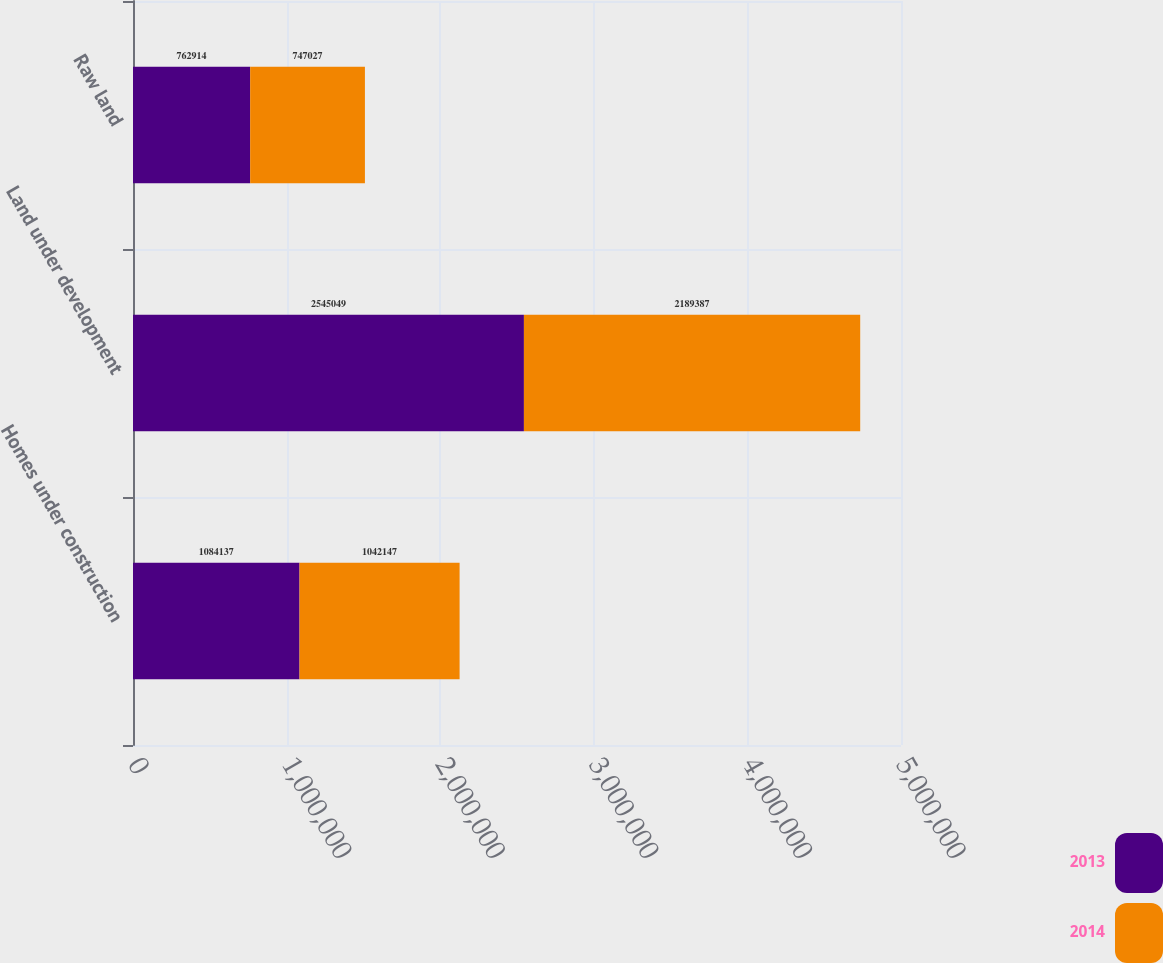Convert chart. <chart><loc_0><loc_0><loc_500><loc_500><stacked_bar_chart><ecel><fcel>Homes under construction<fcel>Land under development<fcel>Raw land<nl><fcel>2013<fcel>1.08414e+06<fcel>2.54505e+06<fcel>762914<nl><fcel>2014<fcel>1.04215e+06<fcel>2.18939e+06<fcel>747027<nl></chart> 